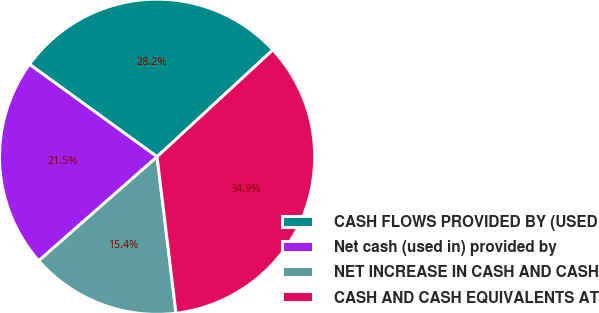Convert chart to OTSL. <chart><loc_0><loc_0><loc_500><loc_500><pie_chart><fcel>CASH FLOWS PROVIDED BY (USED<fcel>Net cash (used in) provided by<fcel>NET INCREASE IN CASH AND CASH<fcel>CASH AND CASH EQUIVALENTS AT<nl><fcel>28.16%<fcel>21.45%<fcel>15.44%<fcel>34.94%<nl></chart> 